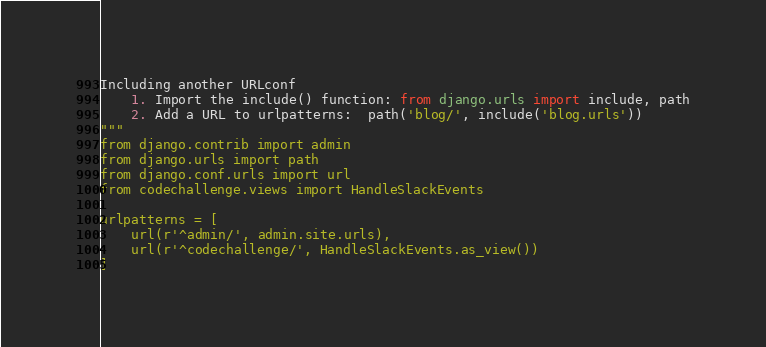Convert code to text. <code><loc_0><loc_0><loc_500><loc_500><_Python_>Including another URLconf
    1. Import the include() function: from django.urls import include, path
    2. Add a URL to urlpatterns:  path('blog/', include('blog.urls'))
"""
from django.contrib import admin
from django.urls import path
from django.conf.urls import url
from codechallenge.views import HandleSlackEvents

urlpatterns = [
    url(r'^admin/', admin.site.urls),
    url(r'^codechallenge/', HandleSlackEvents.as_view())
]
</code> 